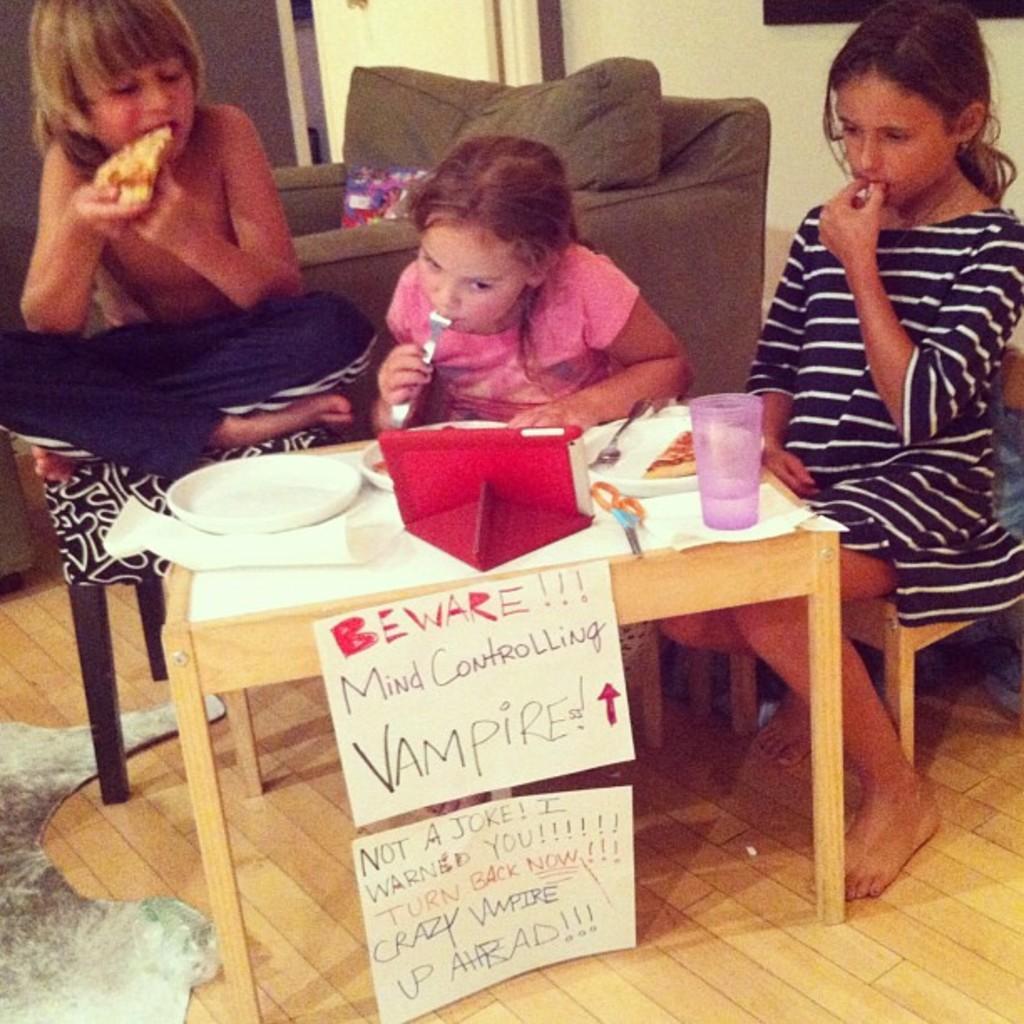Describe this image in one or two sentences. These three persons sitting on the chair. We can see table and sofa. On the table we can see scissor,plate,fork,food. This is floor. Paper attached with table. This person eating food. This person holding spoon. On the background we can see wall. 